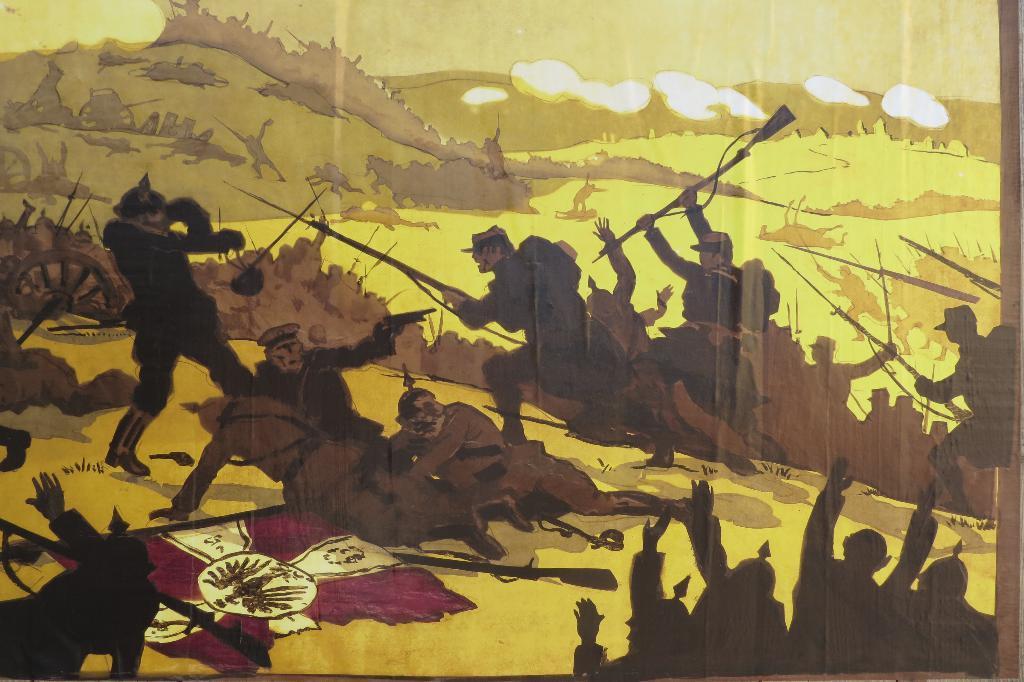Could you give a brief overview of what you see in this image? This image is of a painting. In the center of the image there are people. 